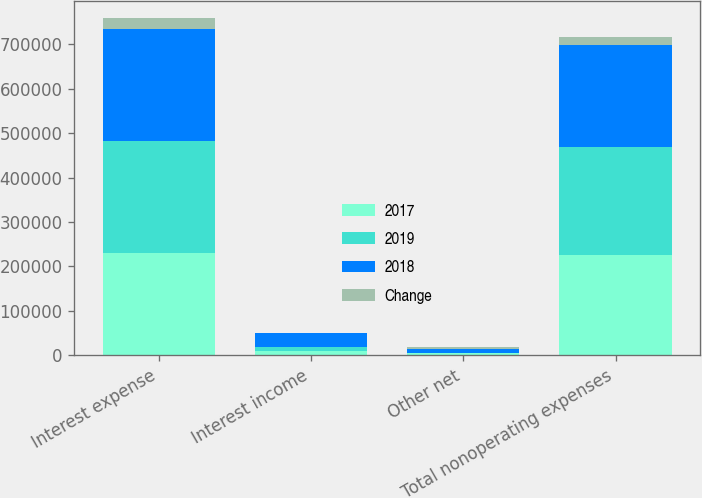Convert chart to OTSL. <chart><loc_0><loc_0><loc_500><loc_500><stacked_bar_chart><ecel><fcel>Interest expense<fcel>Interest income<fcel>Other net<fcel>Total nonoperating expenses<nl><fcel>2017<fcel>229075<fcel>10229<fcel>6034<fcel>224880<nl><fcel>2019<fcel>253589<fcel>9383<fcel>69<fcel>244275<nl><fcel>2018<fcel>250840<fcel>30333<fcel>7507<fcel>228014<nl><fcel>Change<fcel>24514<fcel>846<fcel>5965<fcel>19395<nl></chart> 